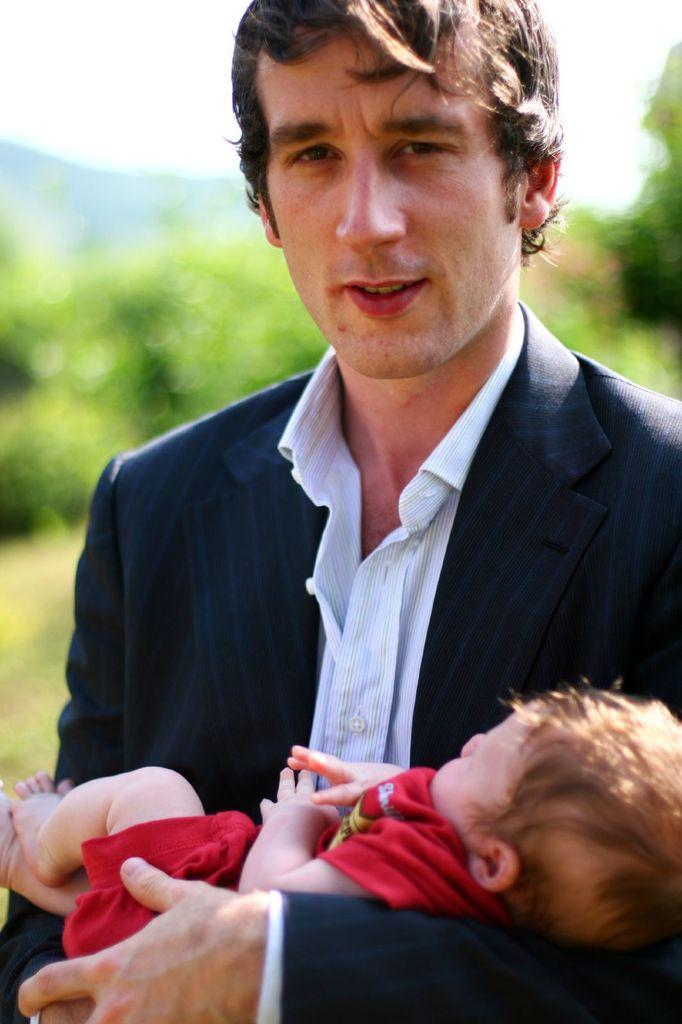What is the main subject in the center of the image? There is a man standing in the center of the image. What is the man doing in the image? The man is holding a baby. What can be seen in the background of the image? There is sky, trees, and a few other objects visible in the background of the image. What type of plate is being used to hold the baby in the image? There is no plate present in the image; the man is holding the baby directly. 